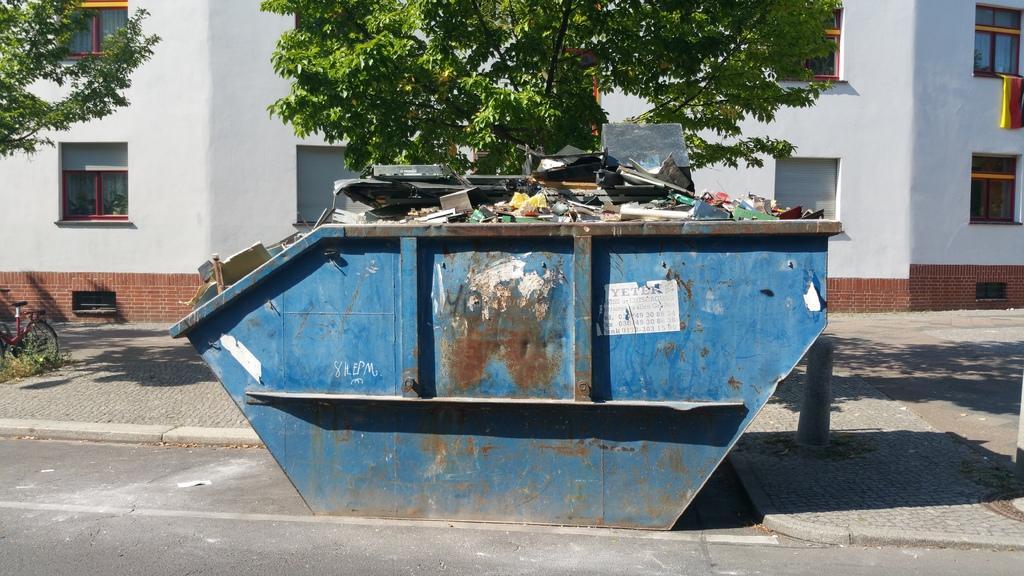Can you describe this image briefly? In this image there is a road at the bottom. There is a bicycle, there is a building, there are windows, trees on the left corner. There are windows and there is an object on the right corner. There is a metal object with scrap in the foreground. There is a tree and a building in the background. 